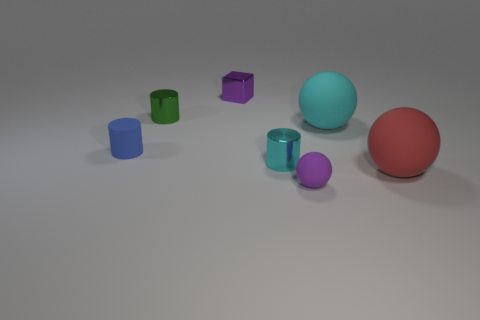What number of blue balls are the same size as the block?
Provide a succinct answer. 0. What is the color of the rubber object that is right of the cyan rubber ball?
Make the answer very short. Red. What number of other objects are the same size as the blue cylinder?
Give a very brief answer. 4. What size is the rubber thing that is both behind the cyan shiny thing and on the right side of the tiny purple matte object?
Provide a short and direct response. Large. Do the rubber cylinder and the shiny cylinder that is in front of the rubber cylinder have the same color?
Ensure brevity in your answer.  No. Are there any big brown matte objects that have the same shape as the blue object?
Provide a short and direct response. No. How many objects are cylinders or big spheres that are behind the small rubber cylinder?
Offer a very short reply. 4. How many other things are made of the same material as the small green cylinder?
Make the answer very short. 2. How many objects are either small green things or blue cylinders?
Provide a succinct answer. 2. Is the number of purple spheres behind the red rubber thing greater than the number of green shiny objects left of the tiny green cylinder?
Ensure brevity in your answer.  No. 